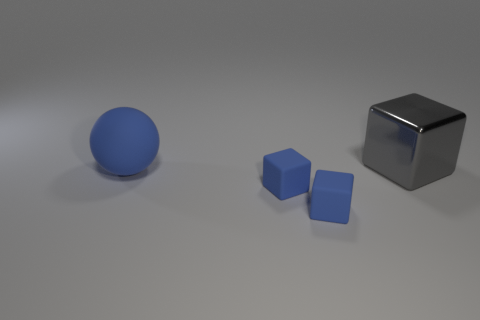What does the arrangement of these objects make you think in terms of their possible use or symbolism? The arrangement of these objects, isolated and with no immediately apparent context, could be interpreted in many ways. For example, it might symbolize basic building blocks or fundamental elements, denoting simplicity, precision, or the concept of starting points in a creative or problem-solving process. 